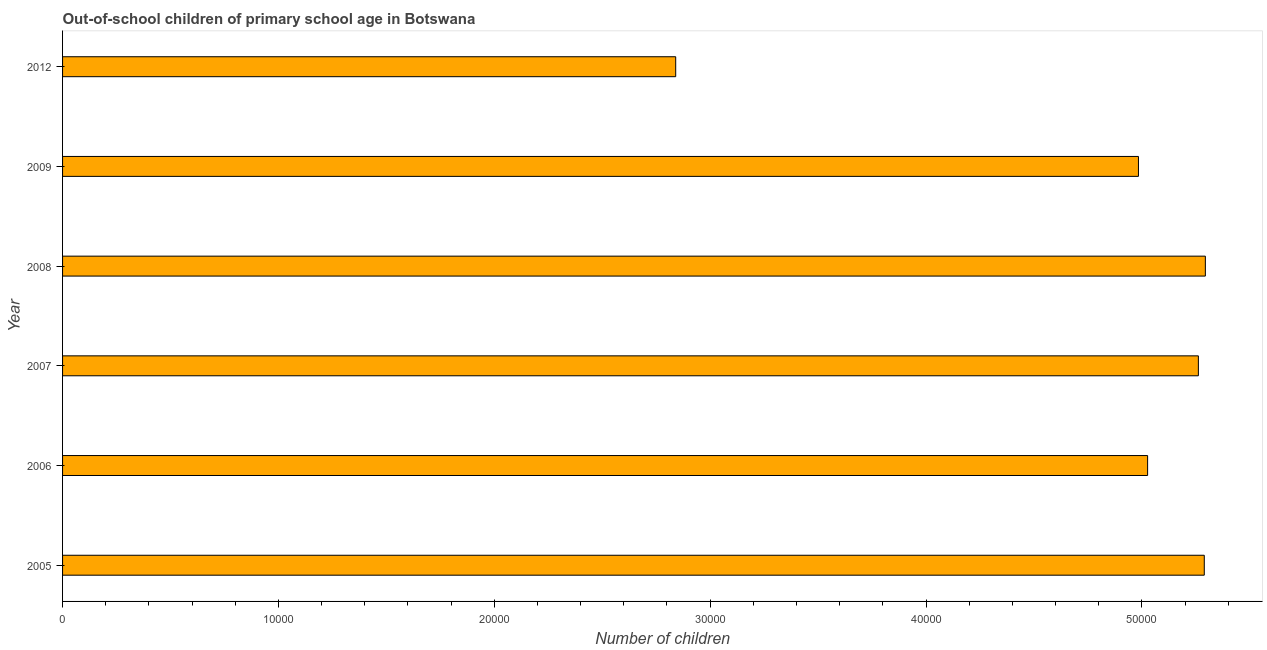Does the graph contain grids?
Provide a short and direct response. No. What is the title of the graph?
Provide a short and direct response. Out-of-school children of primary school age in Botswana. What is the label or title of the X-axis?
Keep it short and to the point. Number of children. What is the label or title of the Y-axis?
Give a very brief answer. Year. What is the number of out-of-school children in 2006?
Provide a succinct answer. 5.03e+04. Across all years, what is the maximum number of out-of-school children?
Provide a succinct answer. 5.29e+04. Across all years, what is the minimum number of out-of-school children?
Provide a succinct answer. 2.84e+04. What is the sum of the number of out-of-school children?
Offer a very short reply. 2.87e+05. What is the difference between the number of out-of-school children in 2005 and 2009?
Your answer should be very brief. 3049. What is the average number of out-of-school children per year?
Your answer should be very brief. 4.78e+04. What is the median number of out-of-school children?
Make the answer very short. 5.14e+04. In how many years, is the number of out-of-school children greater than 52000 ?
Give a very brief answer. 3. Do a majority of the years between 2006 and 2012 (inclusive) have number of out-of-school children greater than 12000 ?
Make the answer very short. Yes. What is the ratio of the number of out-of-school children in 2007 to that in 2008?
Give a very brief answer. 0.99. Is the number of out-of-school children in 2008 less than that in 2012?
Offer a very short reply. No. What is the difference between the highest and the second highest number of out-of-school children?
Your response must be concise. 50. Is the sum of the number of out-of-school children in 2007 and 2012 greater than the maximum number of out-of-school children across all years?
Provide a short and direct response. Yes. What is the difference between the highest and the lowest number of out-of-school children?
Offer a terse response. 2.45e+04. Are all the bars in the graph horizontal?
Your answer should be compact. Yes. How many years are there in the graph?
Ensure brevity in your answer.  6. Are the values on the major ticks of X-axis written in scientific E-notation?
Your answer should be compact. No. What is the Number of children of 2005?
Give a very brief answer. 5.29e+04. What is the Number of children in 2006?
Keep it short and to the point. 5.03e+04. What is the Number of children of 2007?
Offer a terse response. 5.26e+04. What is the Number of children of 2008?
Make the answer very short. 5.29e+04. What is the Number of children of 2009?
Your answer should be compact. 4.98e+04. What is the Number of children of 2012?
Provide a short and direct response. 2.84e+04. What is the difference between the Number of children in 2005 and 2006?
Ensure brevity in your answer.  2625. What is the difference between the Number of children in 2005 and 2007?
Give a very brief answer. 273. What is the difference between the Number of children in 2005 and 2008?
Your response must be concise. -50. What is the difference between the Number of children in 2005 and 2009?
Keep it short and to the point. 3049. What is the difference between the Number of children in 2005 and 2012?
Your answer should be compact. 2.45e+04. What is the difference between the Number of children in 2006 and 2007?
Your answer should be very brief. -2352. What is the difference between the Number of children in 2006 and 2008?
Make the answer very short. -2675. What is the difference between the Number of children in 2006 and 2009?
Keep it short and to the point. 424. What is the difference between the Number of children in 2006 and 2012?
Your answer should be compact. 2.19e+04. What is the difference between the Number of children in 2007 and 2008?
Your answer should be very brief. -323. What is the difference between the Number of children in 2007 and 2009?
Your answer should be very brief. 2776. What is the difference between the Number of children in 2007 and 2012?
Give a very brief answer. 2.42e+04. What is the difference between the Number of children in 2008 and 2009?
Your answer should be very brief. 3099. What is the difference between the Number of children in 2008 and 2012?
Provide a succinct answer. 2.45e+04. What is the difference between the Number of children in 2009 and 2012?
Ensure brevity in your answer.  2.14e+04. What is the ratio of the Number of children in 2005 to that in 2006?
Provide a short and direct response. 1.05. What is the ratio of the Number of children in 2005 to that in 2008?
Your answer should be compact. 1. What is the ratio of the Number of children in 2005 to that in 2009?
Offer a very short reply. 1.06. What is the ratio of the Number of children in 2005 to that in 2012?
Your answer should be very brief. 1.86. What is the ratio of the Number of children in 2006 to that in 2007?
Offer a terse response. 0.95. What is the ratio of the Number of children in 2006 to that in 2008?
Offer a terse response. 0.95. What is the ratio of the Number of children in 2006 to that in 2012?
Ensure brevity in your answer.  1.77. What is the ratio of the Number of children in 2007 to that in 2008?
Keep it short and to the point. 0.99. What is the ratio of the Number of children in 2007 to that in 2009?
Provide a short and direct response. 1.06. What is the ratio of the Number of children in 2007 to that in 2012?
Keep it short and to the point. 1.85. What is the ratio of the Number of children in 2008 to that in 2009?
Your answer should be compact. 1.06. What is the ratio of the Number of children in 2008 to that in 2012?
Offer a very short reply. 1.86. What is the ratio of the Number of children in 2009 to that in 2012?
Offer a terse response. 1.75. 